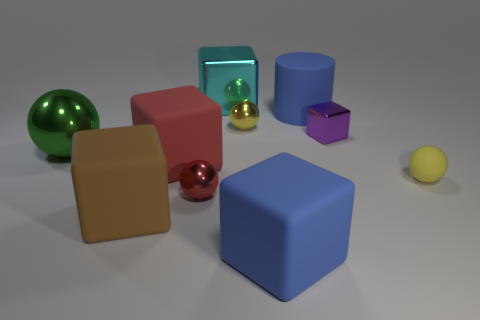Subtract 1 balls. How many balls are left? 3 Subtract all big cyan cubes. How many cubes are left? 4 Subtract all purple cubes. How many cubes are left? 4 Subtract all yellow cubes. Subtract all yellow cylinders. How many cubes are left? 5 Subtract all spheres. How many objects are left? 6 Subtract 0 purple spheres. How many objects are left? 10 Subtract all big blue matte cubes. Subtract all blue matte cubes. How many objects are left? 8 Add 9 green spheres. How many green spheres are left? 10 Add 4 large rubber things. How many large rubber things exist? 8 